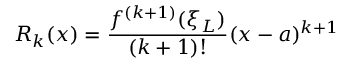<formula> <loc_0><loc_0><loc_500><loc_500>R _ { k } ( x ) = { \frac { f ^ { ( k + 1 ) } ( \xi _ { L } ) } { ( k + 1 ) ! } } ( x - a ) ^ { k + 1 }</formula> 